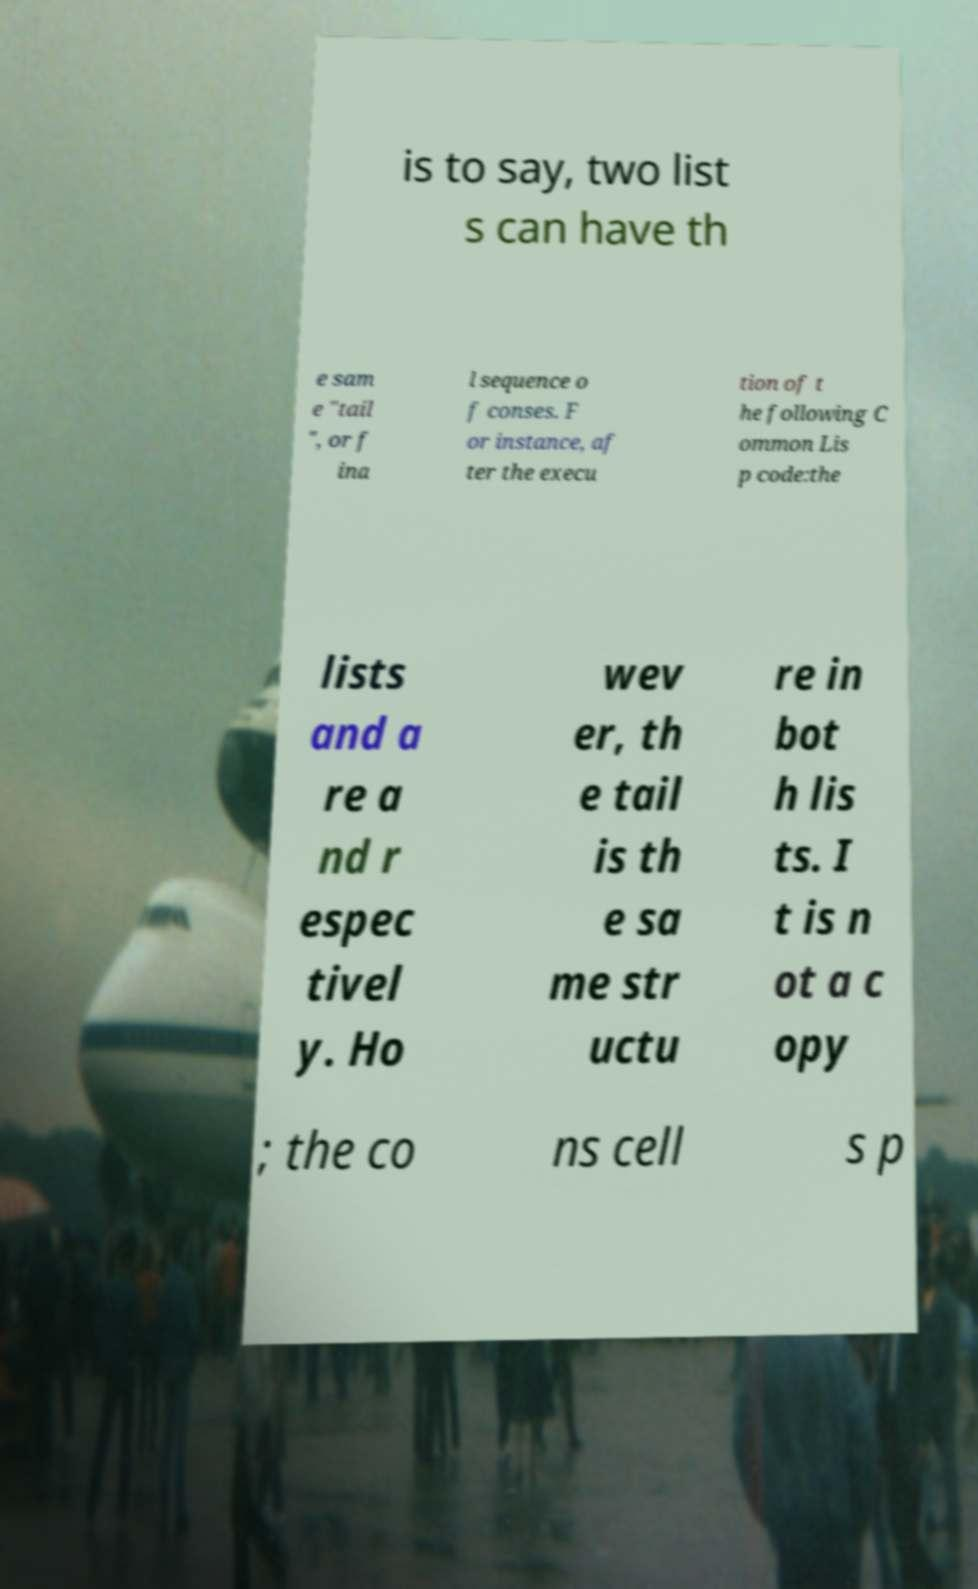Could you assist in decoding the text presented in this image and type it out clearly? is to say, two list s can have th e sam e "tail ", or f ina l sequence o f conses. F or instance, af ter the execu tion of t he following C ommon Lis p code:the lists and a re a nd r espec tivel y. Ho wev er, th e tail is th e sa me str uctu re in bot h lis ts. I t is n ot a c opy ; the co ns cell s p 